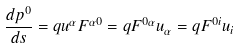Convert formula to latex. <formula><loc_0><loc_0><loc_500><loc_500>\frac { d p ^ { 0 } } { d s } = q u ^ { \alpha } F ^ { \alpha 0 } = q F ^ { 0 \alpha } u _ { \alpha } = q F ^ { 0 i } u _ { i }</formula> 